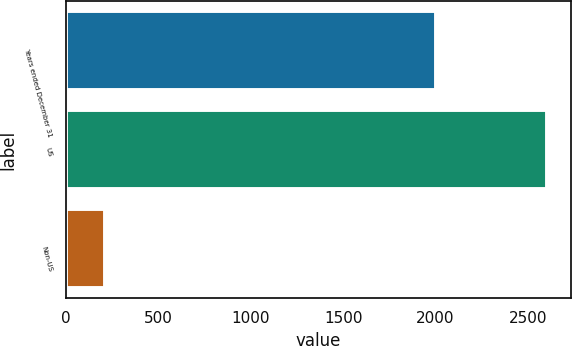Convert chart to OTSL. <chart><loc_0><loc_0><loc_500><loc_500><bar_chart><fcel>Years ended December 31<fcel>US<fcel>Non-US<nl><fcel>2005<fcel>2605<fcel>214<nl></chart> 